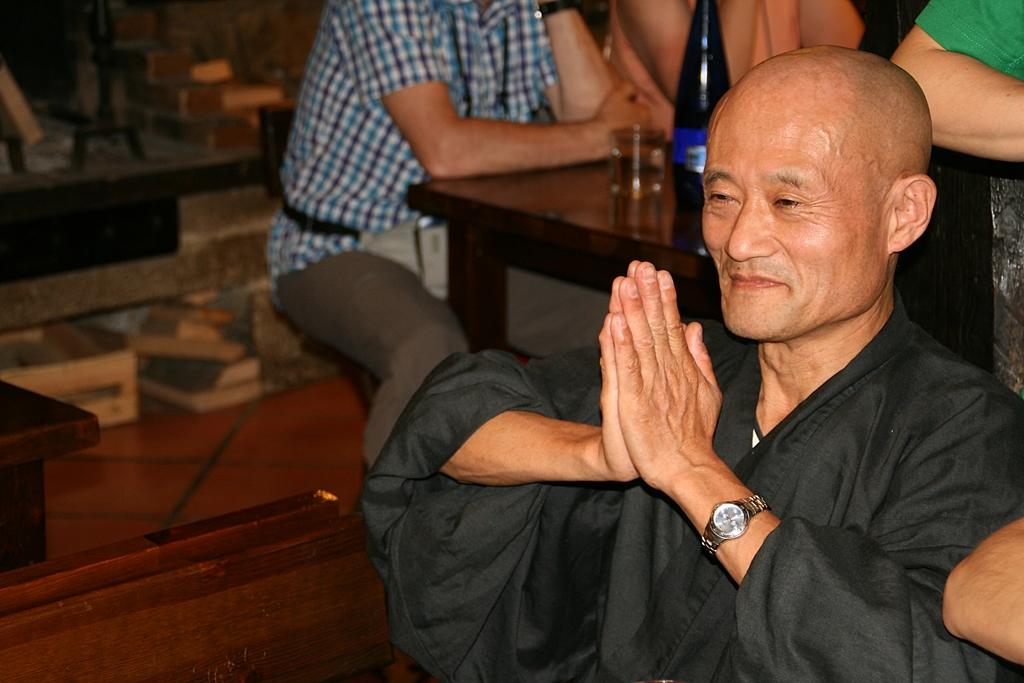What are the people in the image doing? The people are sitting near the table in the image. What can be seen on the table? There is a bottle and a glass on the table. What type of material is used for the objects on or near the table? There are wooden objects on or near the table. What is visible in the background of the image? There is a wall visible in the background. What caption is written on the wall in the image? There is no caption written on the wall in the image; only the wall itself is visible. What stage of growth can be observed in the people sitting near the table? The provided facts do not give any information about the people's stage of growth, so it cannot be determined from the image. 